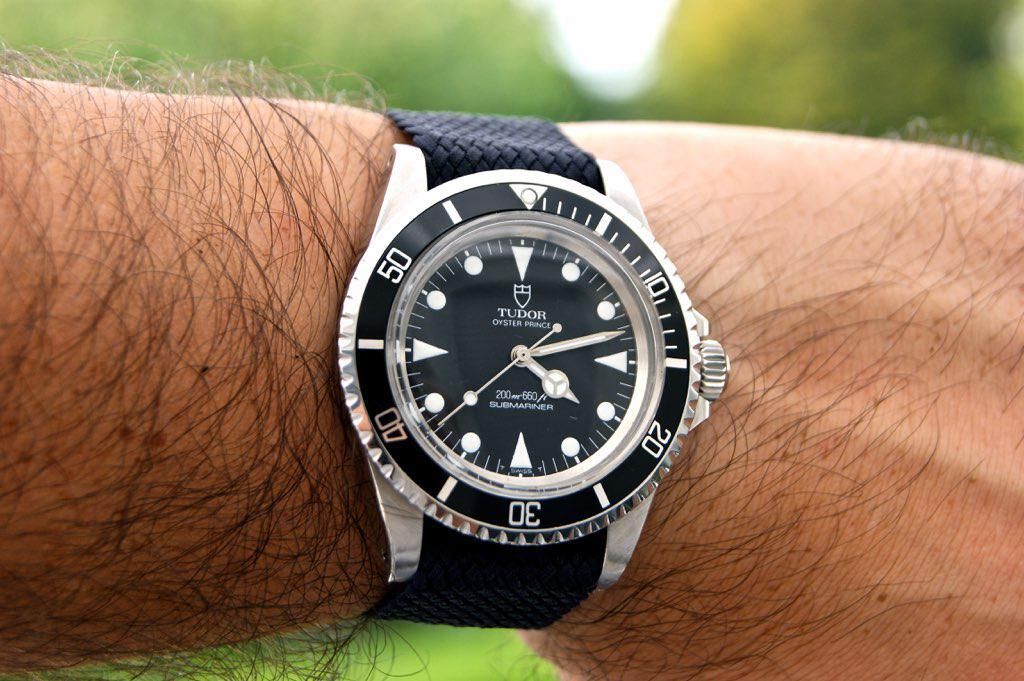<image>
Relay a brief, clear account of the picture shown. Person wearing a wrist watch that says TUDOR on the face. 